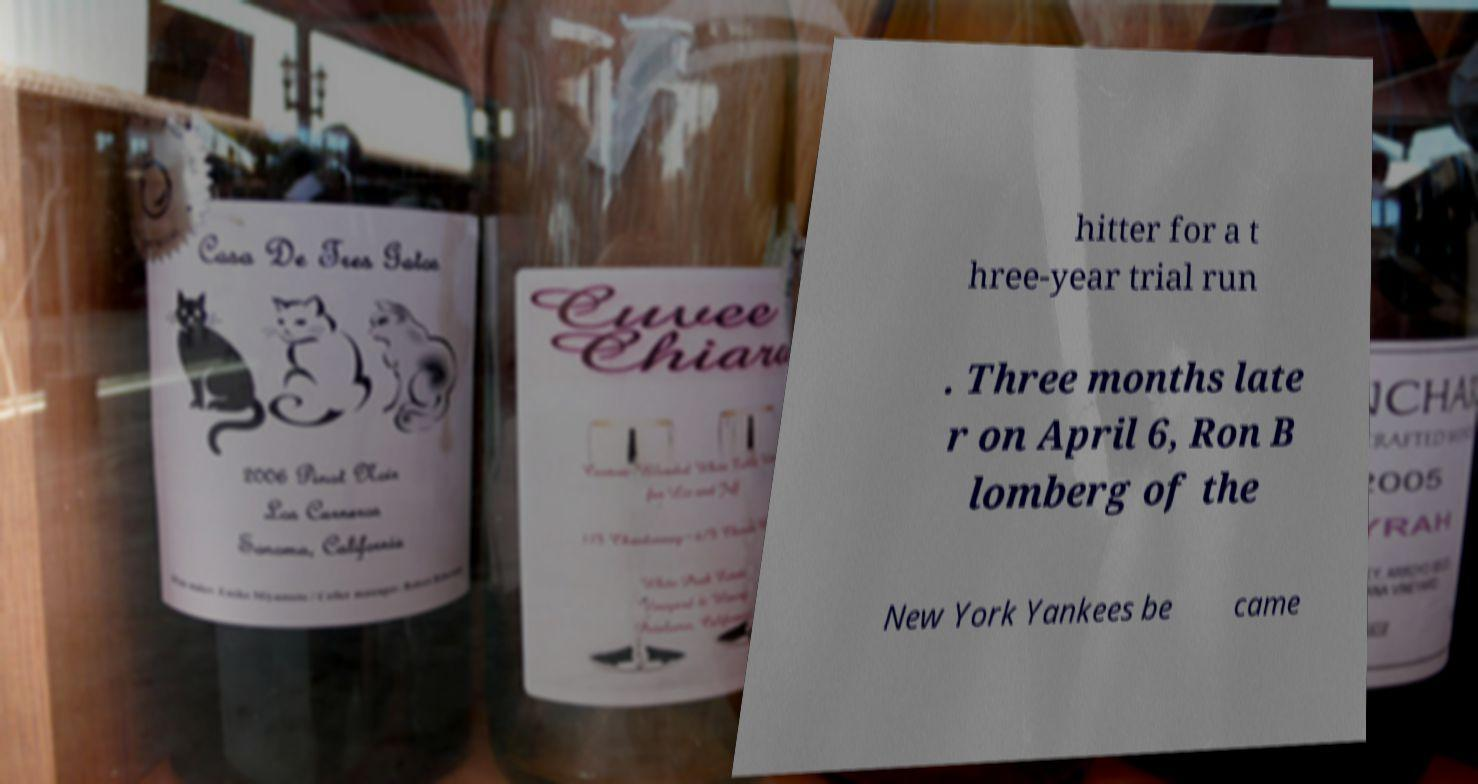There's text embedded in this image that I need extracted. Can you transcribe it verbatim? hitter for a t hree-year trial run . Three months late r on April 6, Ron B lomberg of the New York Yankees be came 